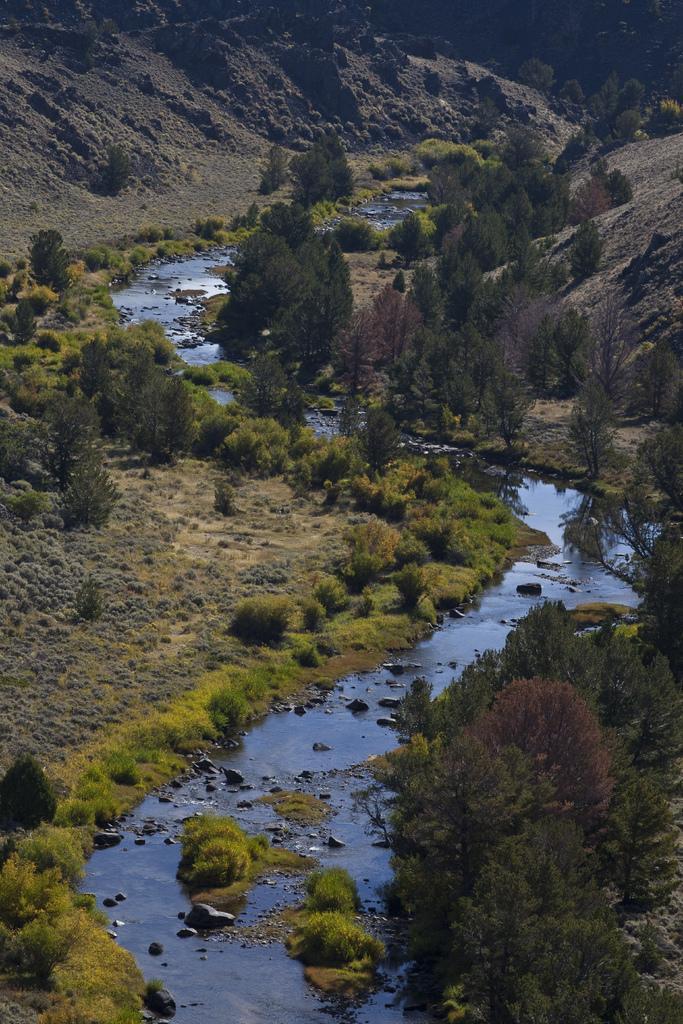Can you describe this image briefly? In the center of the image there is a canal. In the background there are trees and we can see hills. 